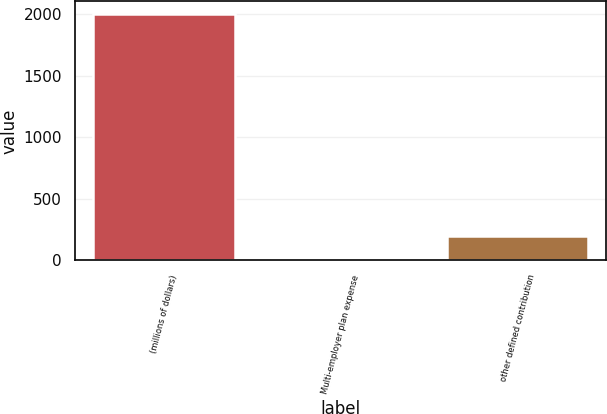<chart> <loc_0><loc_0><loc_500><loc_500><bar_chart><fcel>(millions of dollars)<fcel>Multi-employer plan expense<fcel>other defined contribution<nl><fcel>2005<fcel>0.6<fcel>201.04<nl></chart> 